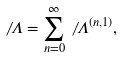Convert formula to latex. <formula><loc_0><loc_0><loc_500><loc_500>\not \, \Lambda = \sum _ { n = 0 } ^ { \infty } \not \, \Lambda ^ { ( n , 1 ) } ,</formula> 